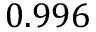Convert formula to latex. <formula><loc_0><loc_0><loc_500><loc_500>0 . 9 9 6</formula> 